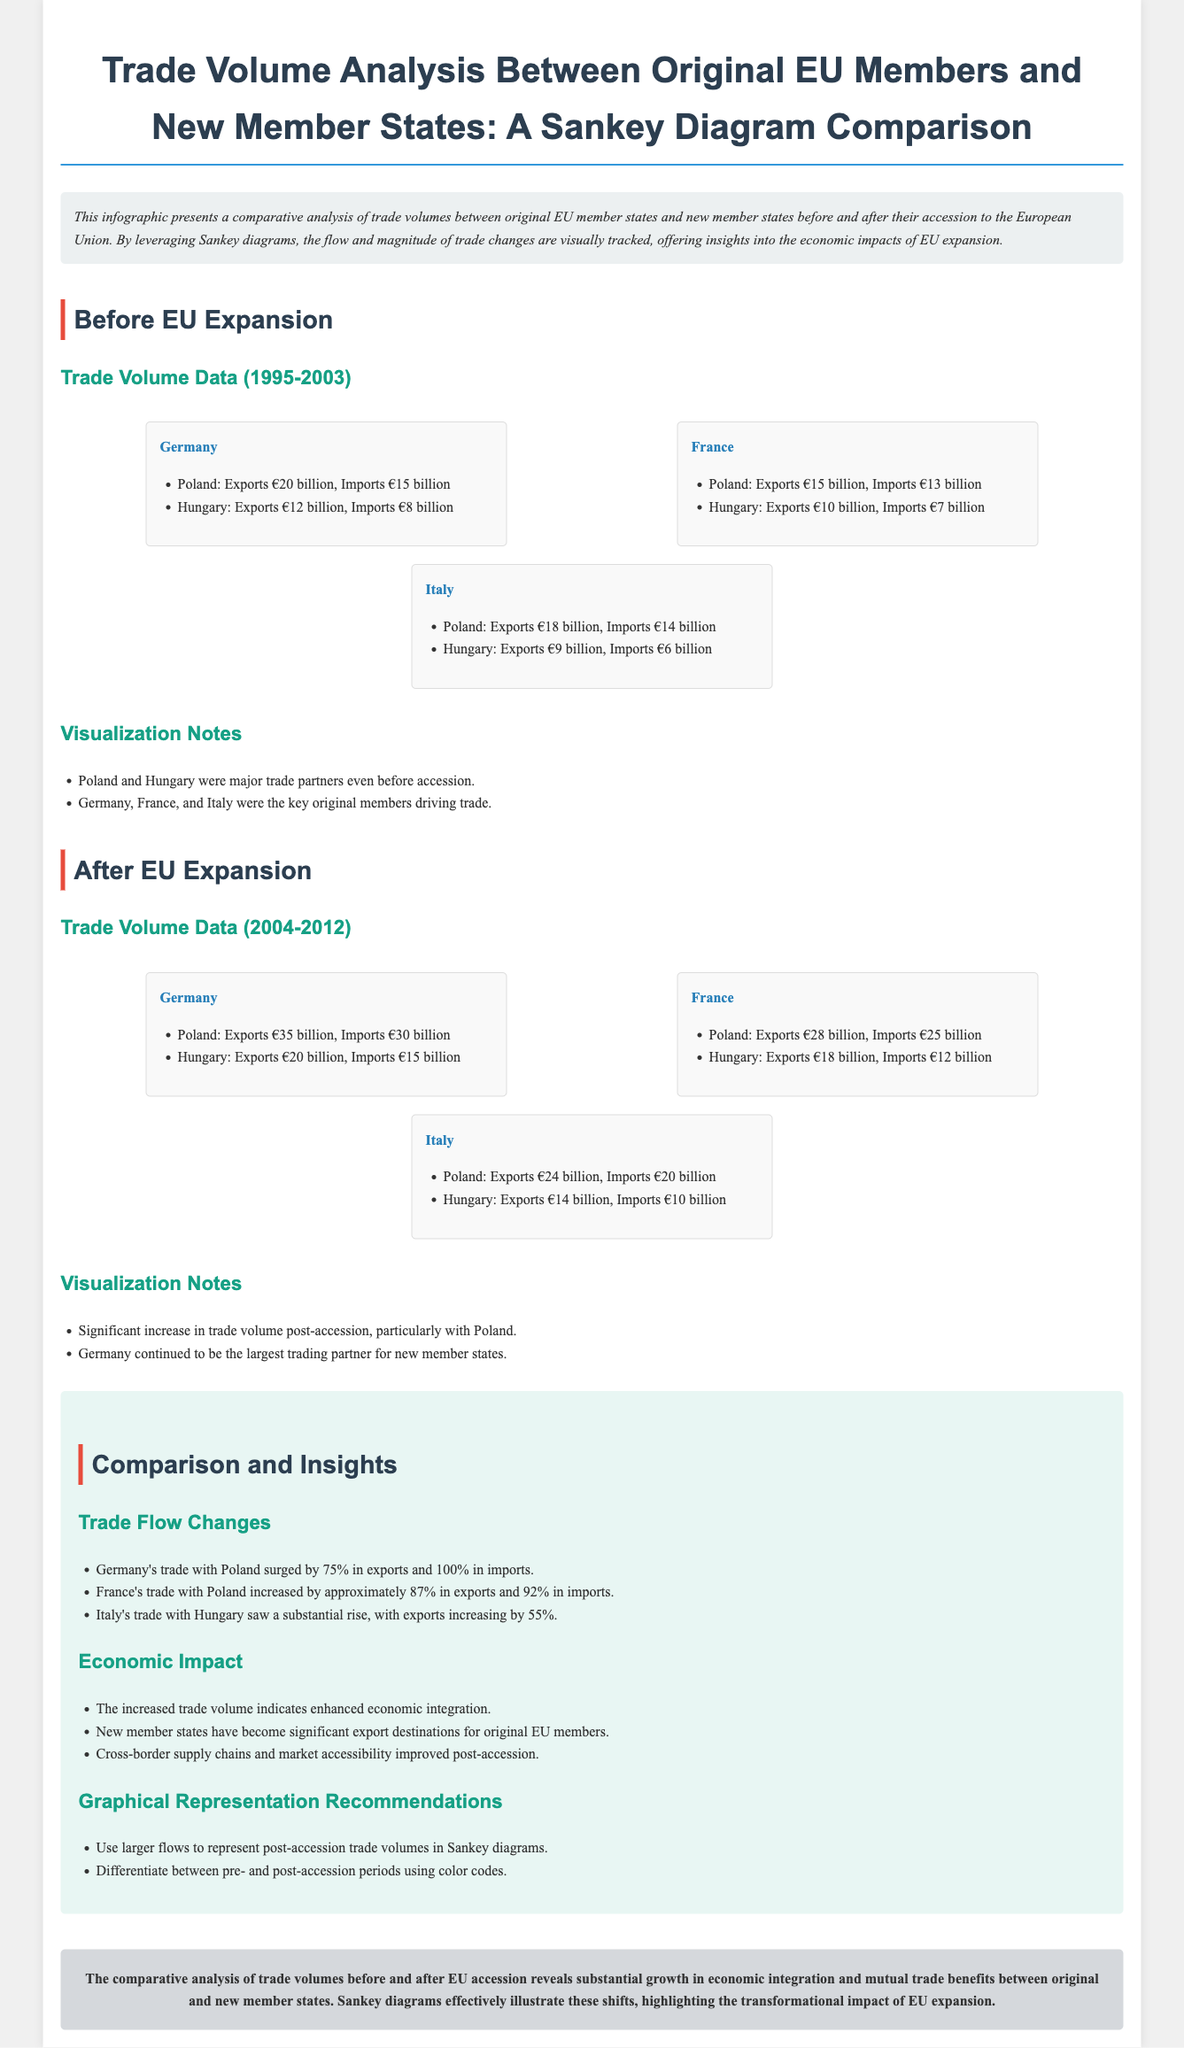What time period does the document cover for trade volume data? The document presents trade volume data from 1995 to 2012, with specific sections for before and after EU expansion.
Answer: 1995-2012 Which country had the highest exports to Poland before EU accession? The highest exports to Poland before accession came from Germany, with €20 billion in exports.
Answer: Germany What was the percentage increase in Germany's imports from Poland after EU accession? The document states that Germany's imports from Poland increased by 100% post-accession.
Answer: 100% Which two original EU member states had the most significant increase in trade volume with Poland after EU expansion? The analysis highlights that both Germany and France saw significant increases in trade volume with Poland after expansion.
Answer: Germany and France What visual representation is used to illustrate the trade volume changes in the document? The document utilizes Sankey diagrams to visually represent trade volume changes between original and new member states.
Answer: Sankey diagrams Which new member state had a significant trading relationship with Italy before EU accession? The document shows Hungary as the new member state with a significant trading relationship with Italy prior to accession.
Answer: Hungary What is one recommendation for graphical representation mentioned in the comparison section? One recommendation is to use larger flows to represent post-accession trade volumes in Sankey diagrams.
Answer: Larger flows What economic trend does the conclusion highlight regarding new member states? The conclusion emphasizes that new member states have become significant export destinations for original EU members.
Answer: Significant export destinations 